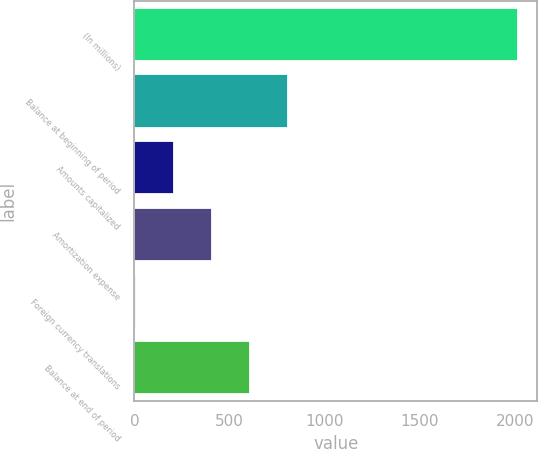Convert chart to OTSL. <chart><loc_0><loc_0><loc_500><loc_500><bar_chart><fcel>(In millions)<fcel>Balance at beginning of period<fcel>Amounts capitalized<fcel>Amortization expense<fcel>Foreign currency translations<fcel>Balance at end of period<nl><fcel>2015<fcel>809.6<fcel>206.9<fcel>407.8<fcel>6<fcel>608.7<nl></chart> 